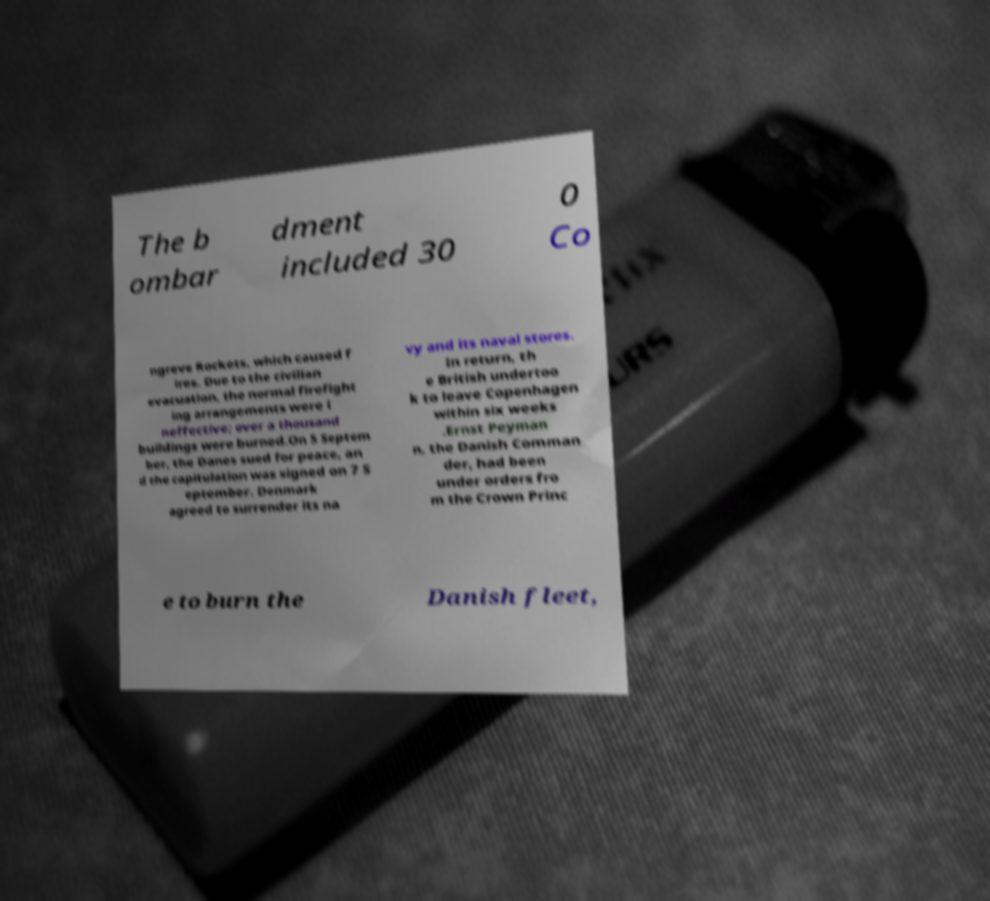There's text embedded in this image that I need extracted. Can you transcribe it verbatim? The b ombar dment included 30 0 Co ngreve Rockets, which caused f ires. Due to the civilian evacuation, the normal firefight ing arrangements were i neffective; over a thousand buildings were burned.On 5 Septem ber, the Danes sued for peace, an d the capitulation was signed on 7 S eptember. Denmark agreed to surrender its na vy and its naval stores. In return, th e British undertoo k to leave Copenhagen within six weeks .Ernst Peyman n, the Danish Comman der, had been under orders fro m the Crown Princ e to burn the Danish fleet, 